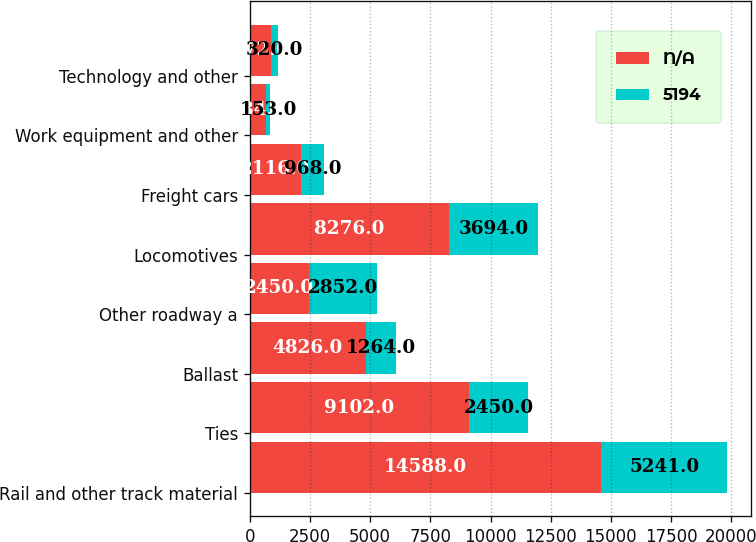Convert chart to OTSL. <chart><loc_0><loc_0><loc_500><loc_500><stacked_bar_chart><ecel><fcel>Rail and other track material<fcel>Ties<fcel>Ballast<fcel>Other roadway a<fcel>Locomotives<fcel>Freight cars<fcel>Work equipment and other<fcel>Technology and other<nl><fcel>nan<fcel>14588<fcel>9102<fcel>4826<fcel>2450<fcel>8276<fcel>2116<fcel>684<fcel>872<nl><fcel>5194<fcel>5241<fcel>2450<fcel>1264<fcel>2852<fcel>3694<fcel>968<fcel>153<fcel>320<nl></chart> 